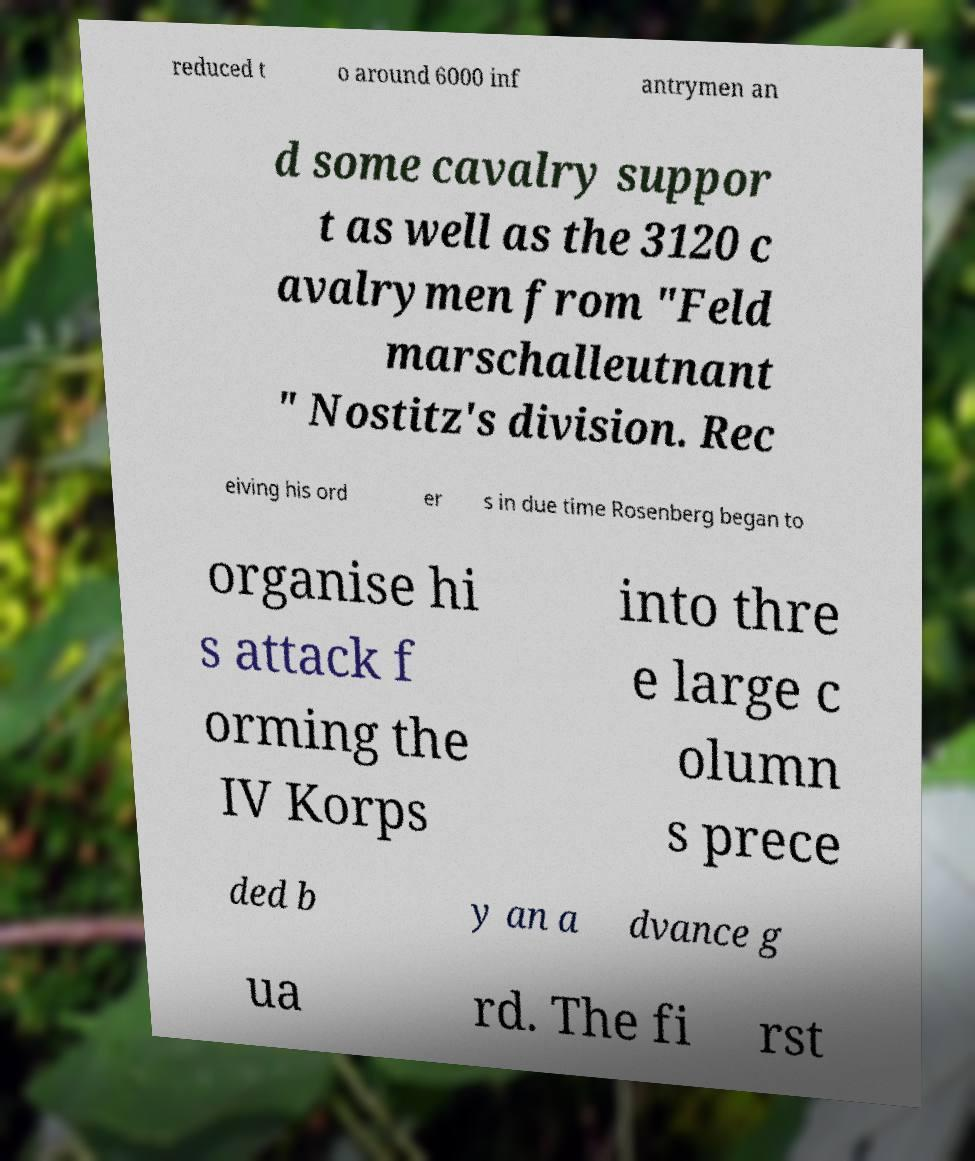Can you accurately transcribe the text from the provided image for me? reduced t o around 6000 inf antrymen an d some cavalry suppor t as well as the 3120 c avalrymen from "Feld marschalleutnant " Nostitz's division. Rec eiving his ord er s in due time Rosenberg began to organise hi s attack f orming the IV Korps into thre e large c olumn s prece ded b y an a dvance g ua rd. The fi rst 